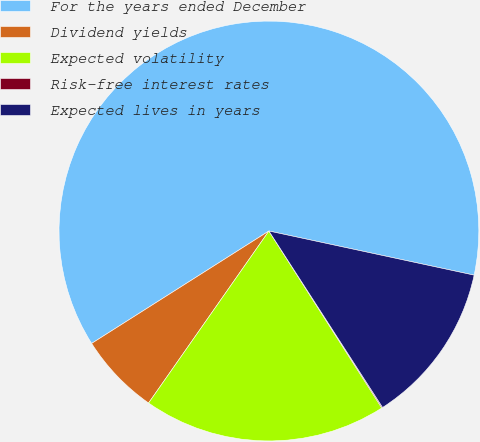Convert chart to OTSL. <chart><loc_0><loc_0><loc_500><loc_500><pie_chart><fcel>For the years ended December<fcel>Dividend yields<fcel>Expected volatility<fcel>Risk-free interest rates<fcel>Expected lives in years<nl><fcel>62.36%<fcel>6.29%<fcel>18.75%<fcel>0.07%<fcel>12.52%<nl></chart> 